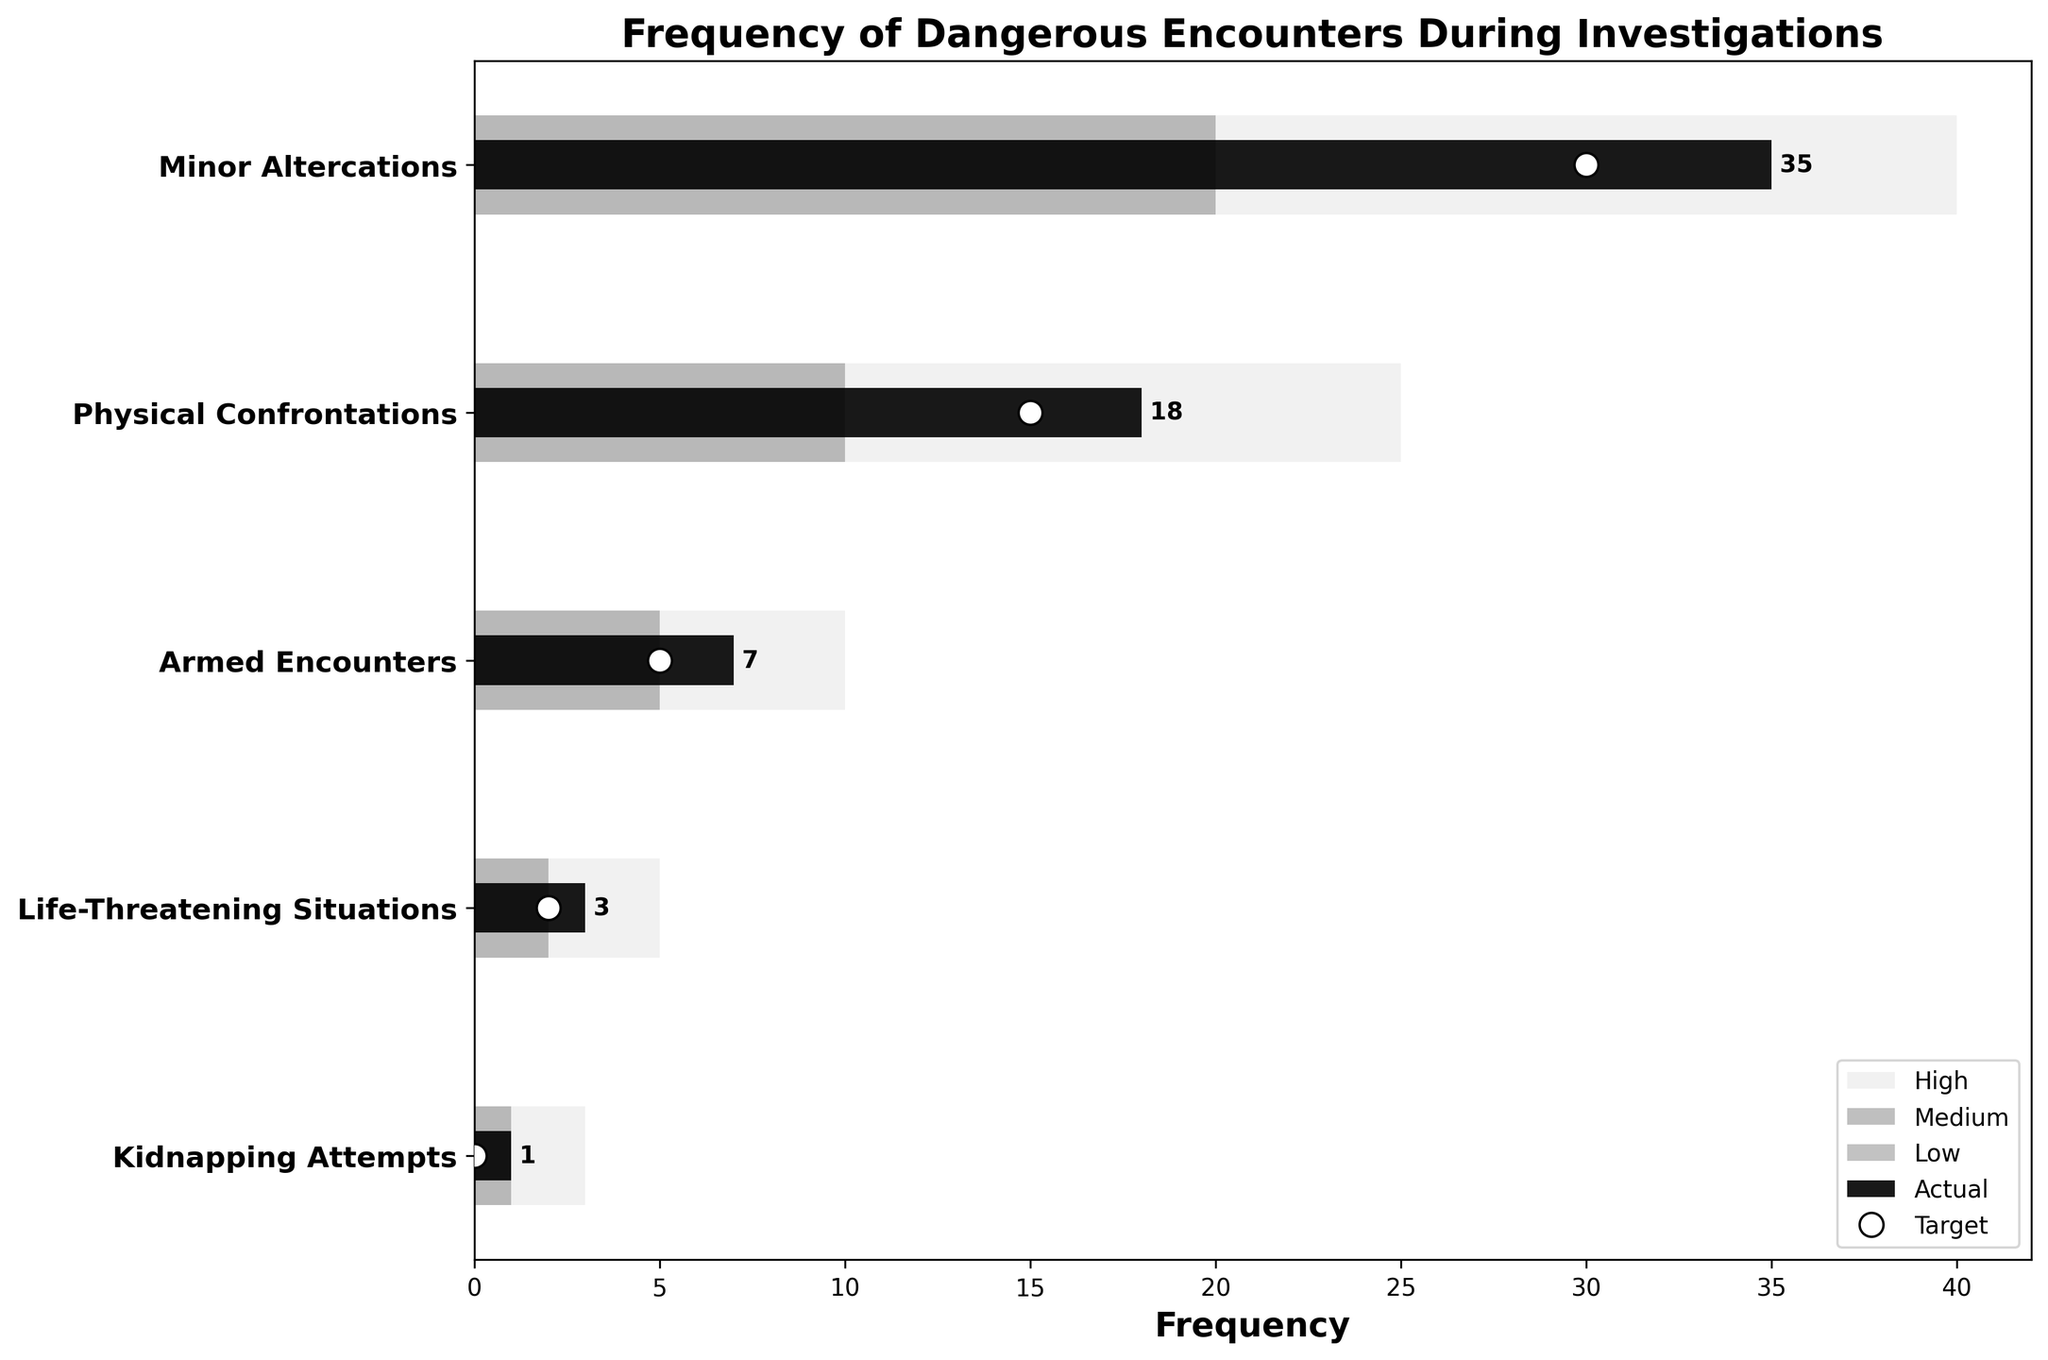What is the title of the chart? The title of the chart is displayed prominently at the top, and it clearly describes what the chart is about.
Answer: Frequency of Dangerous Encounters During Investigations What is the frequency of Physical Confrontations? To find this, locate the "Physical Confrontations" category and look at the length of the black bar representing actual occurrences.
Answer: 18 Which severity category has the highest number of actual occurrences? Compare the black bars representing actual occurrences across all categories. The longest bar indicates the highest frequency.
Answer: Minor Altercations How many life-threatening situations were there compared to the target? Look at the "Life-Threatening Situations" category. The black bar representing actual occurrences is 3, and the white dot representing the target is at 2.
Answer: 3 actual vs. 2 target What is the difference in frequency between Minor Altercations and Armed Encounters? Subtract the frequency of Armed Encounters (7) from Minor Altercations (35) to find the difference.
Answer: 28 Is the actual frequency of Kidnapping Attempts above the low range? Check the bar representing the low range for "Kidnapping Attempts" which starts at 0. Now observe the black bar representing actual occurrences. If it is above the low range bar, the actual frequency is above the low range.
Answer: No Which severity category missed its target the most? Calculate the difference between the actual occurrences and target for each category. Identify the category with the largest positive difference.
Answer: Minor Altercations How do the numbers for Physical Confrontations compare to Minor Altercations in terms of reaching their targets? Refer to the actual and target values for both categories. Check if the actual value exceeds or is behind the target value for each.
Answer: Both exceed targets, but Minor Altercations exceed more What range level does Armed Encounters fall under? Check the position of the black bar representing actual occurrences (7) within the color-coded ranges for Armed Encounters. The medium range spans from 5 to 10.
Answer: Medium How close are the actual frequencies to the target for each category on average? Calculate the differences between actual and target for each category. Then, find the average of these differences. Differences: 5, 3, 2, 1, 1, Average = (5+3+2+1+1)/5 = 2.4
Answer: 2.4 